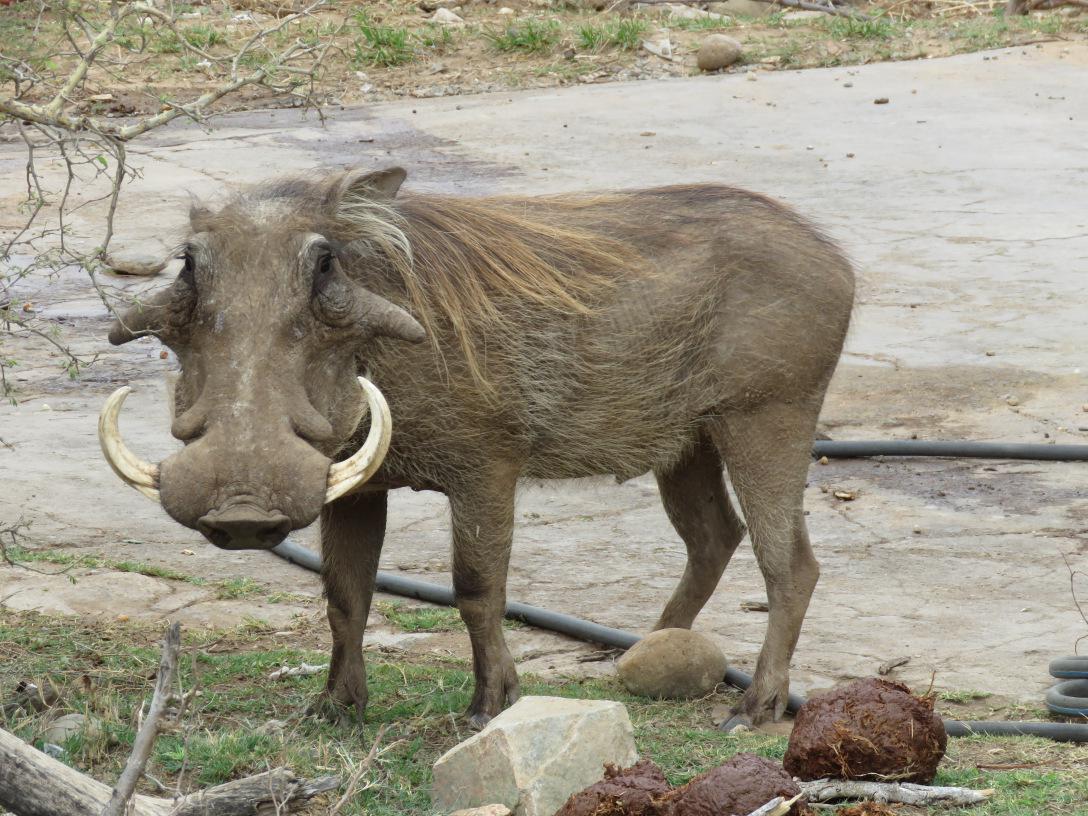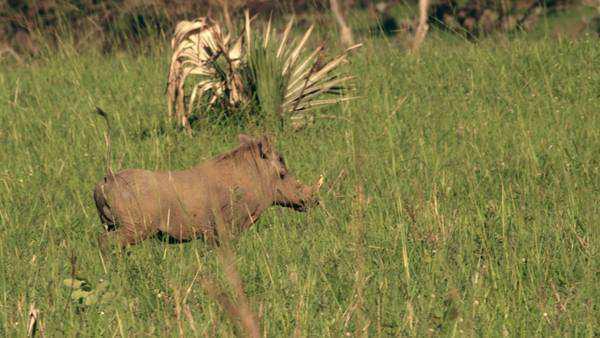The first image is the image on the left, the second image is the image on the right. For the images displayed, is the sentence "There are five warthogs in the left image." factually correct? Answer yes or no. No. 